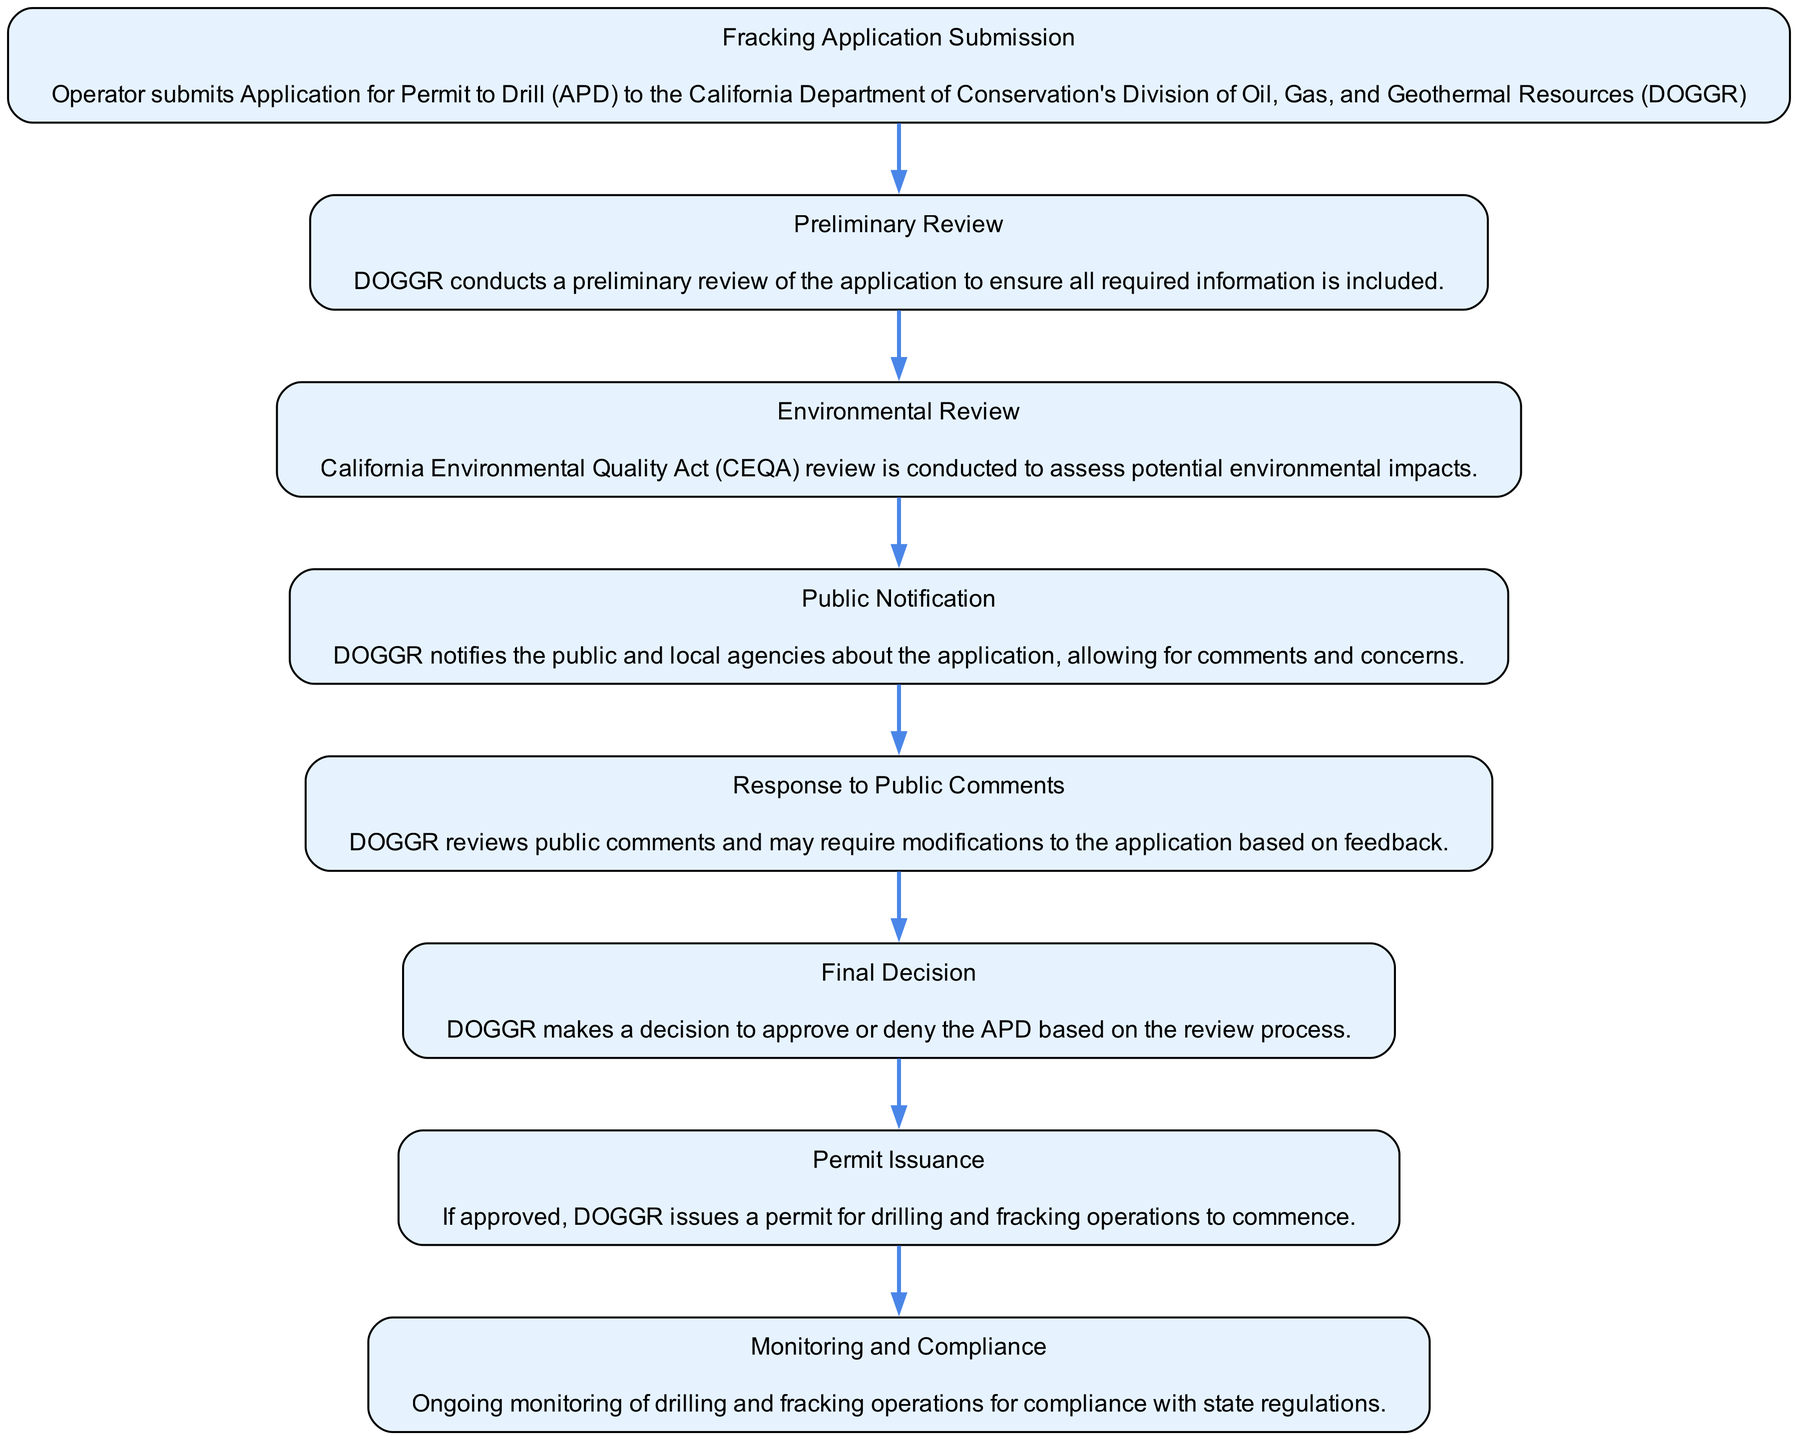What is the first step in the fracking regulatory process? The diagram indicates that the first step is the submission of an Application for Permit to Drill (APD) to DOGGR.
Answer: Fracking Application Submission How many total steps are in the diagram? By counting the distinct steps listed in the flow chart, there are a total of eight steps in the regulatory process.
Answer: Eight Which step follows the Environmental Review? According to the flow chart, the step following the Environmental Review is Public Notification.
Answer: Public Notification What does DOGGR do with public comments? The diagram states that DOGGR reviews public comments and may require modifications to the application based on feedback, indicating a response process.
Answer: Response to Public Comments What is the last step in the fracking regulatory process? The last step, as indicated in the flow chart, is Monitoring and Compliance, which refers to ongoing oversight of operations.
Answer: Monitoring and Compliance Which step involves assessing potential environmental impacts? The flow chart specifies that the Environmental Review step is responsible for assessing potential environmental impacts.
Answer: Environmental Review What occurs after the Final Decision is made? After the Final Decision, if the application is approved, DOGGR issues a permit for drilling operations to begin.
Answer: Permit Issuance Which step includes notifying the public? The step that includes notifying the public is Public Notification, as indicated in the flow chart.
Answer: Public Notification 